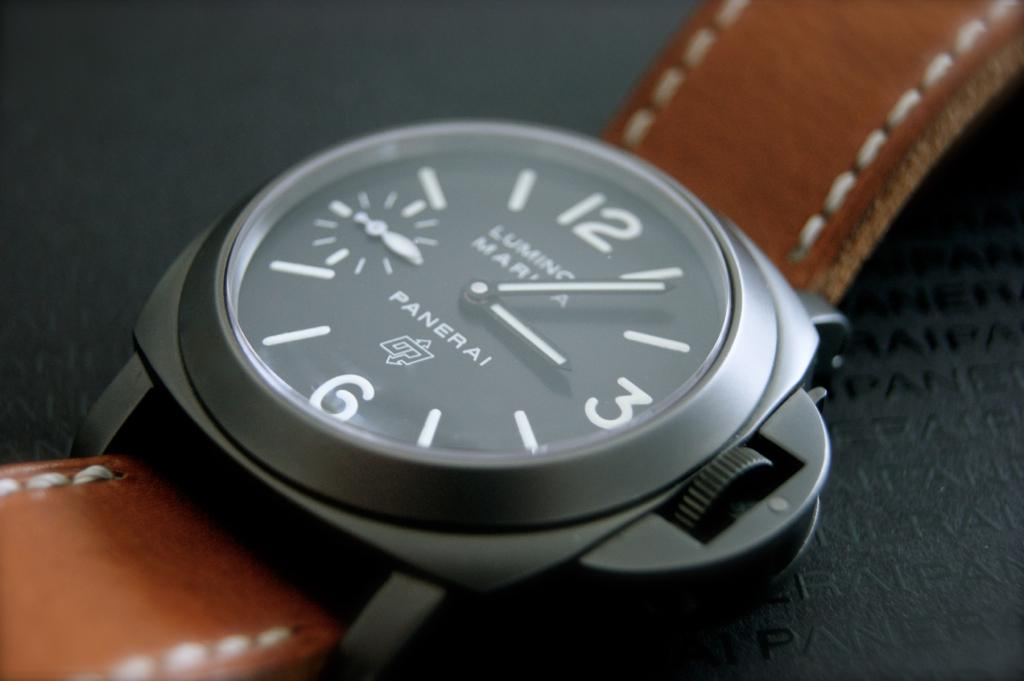Provide a one-sentence caption for the provided image.
Reference OCR token: 12, 16, PAMERAL A Panerai watch with a brown leather strap on it. 